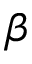<formula> <loc_0><loc_0><loc_500><loc_500>\beta</formula> 